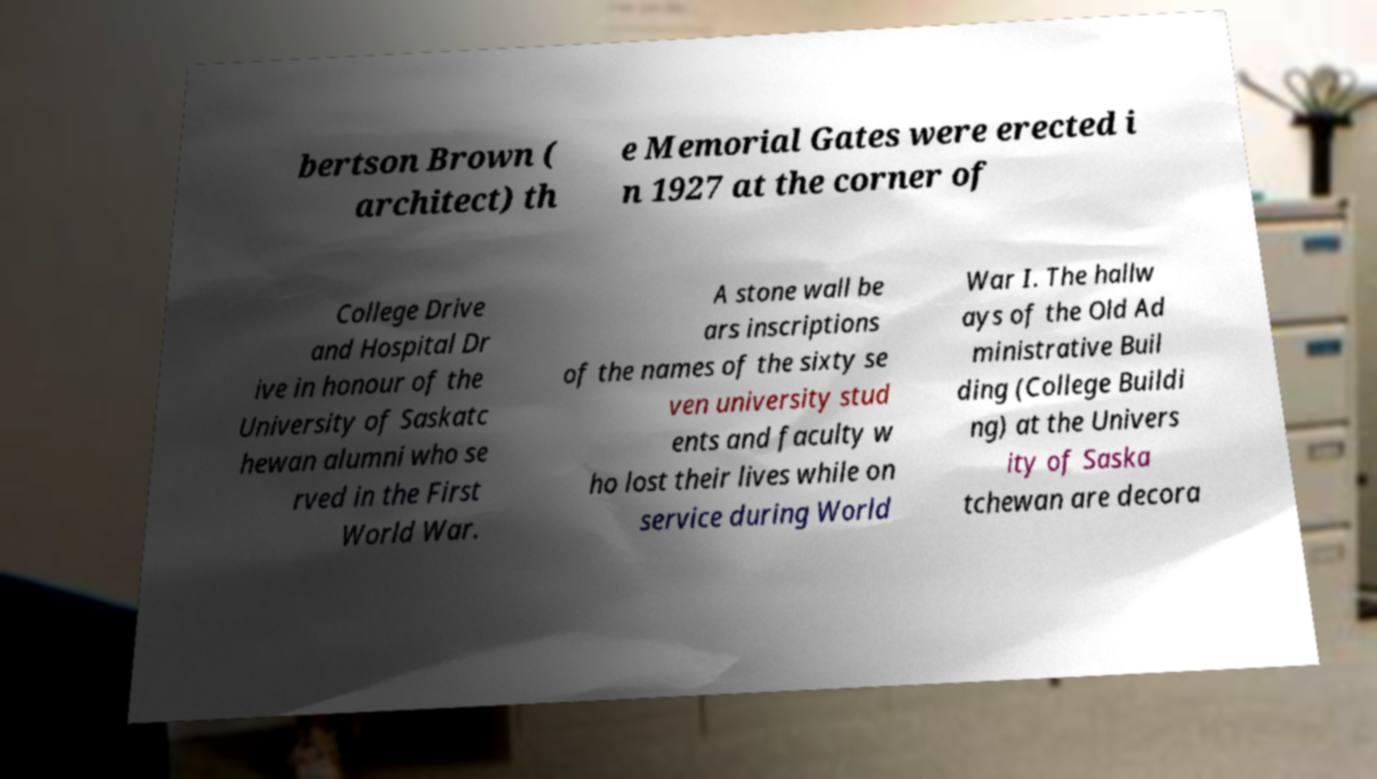For documentation purposes, I need the text within this image transcribed. Could you provide that? bertson Brown ( architect) th e Memorial Gates were erected i n 1927 at the corner of College Drive and Hospital Dr ive in honour of the University of Saskatc hewan alumni who se rved in the First World War. A stone wall be ars inscriptions of the names of the sixty se ven university stud ents and faculty w ho lost their lives while on service during World War I. The hallw ays of the Old Ad ministrative Buil ding (College Buildi ng) at the Univers ity of Saska tchewan are decora 